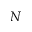<formula> <loc_0><loc_0><loc_500><loc_500>N</formula> 